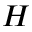<formula> <loc_0><loc_0><loc_500><loc_500>H</formula> 